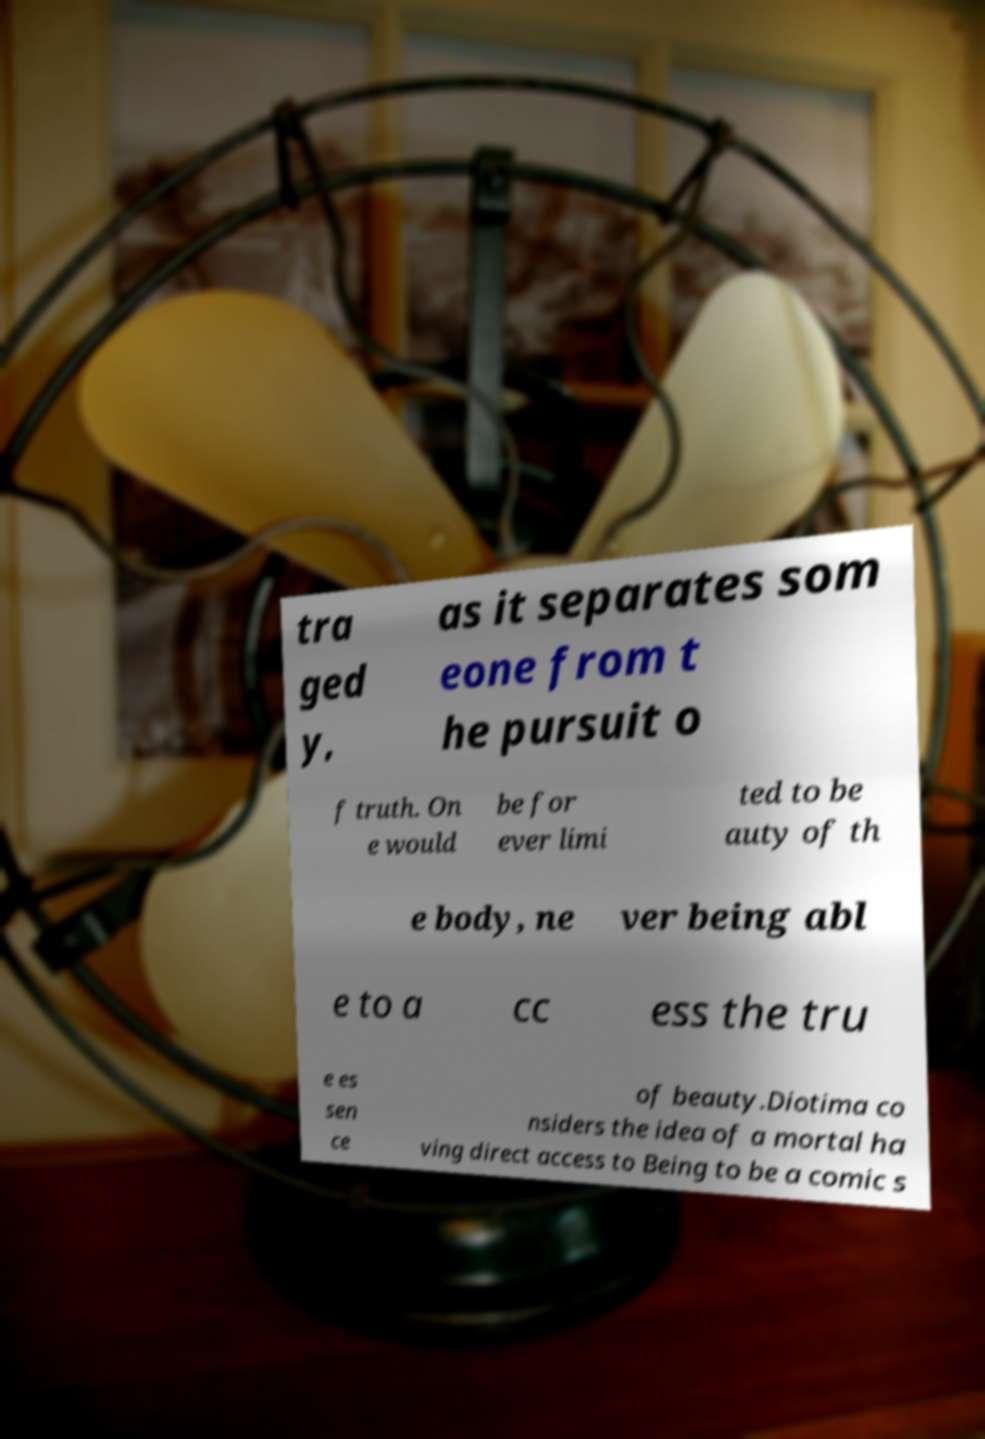What messages or text are displayed in this image? I need them in a readable, typed format. tra ged y, as it separates som eone from t he pursuit o f truth. On e would be for ever limi ted to be auty of th e body, ne ver being abl e to a cc ess the tru e es sen ce of beauty.Diotima co nsiders the idea of a mortal ha ving direct access to Being to be a comic s 